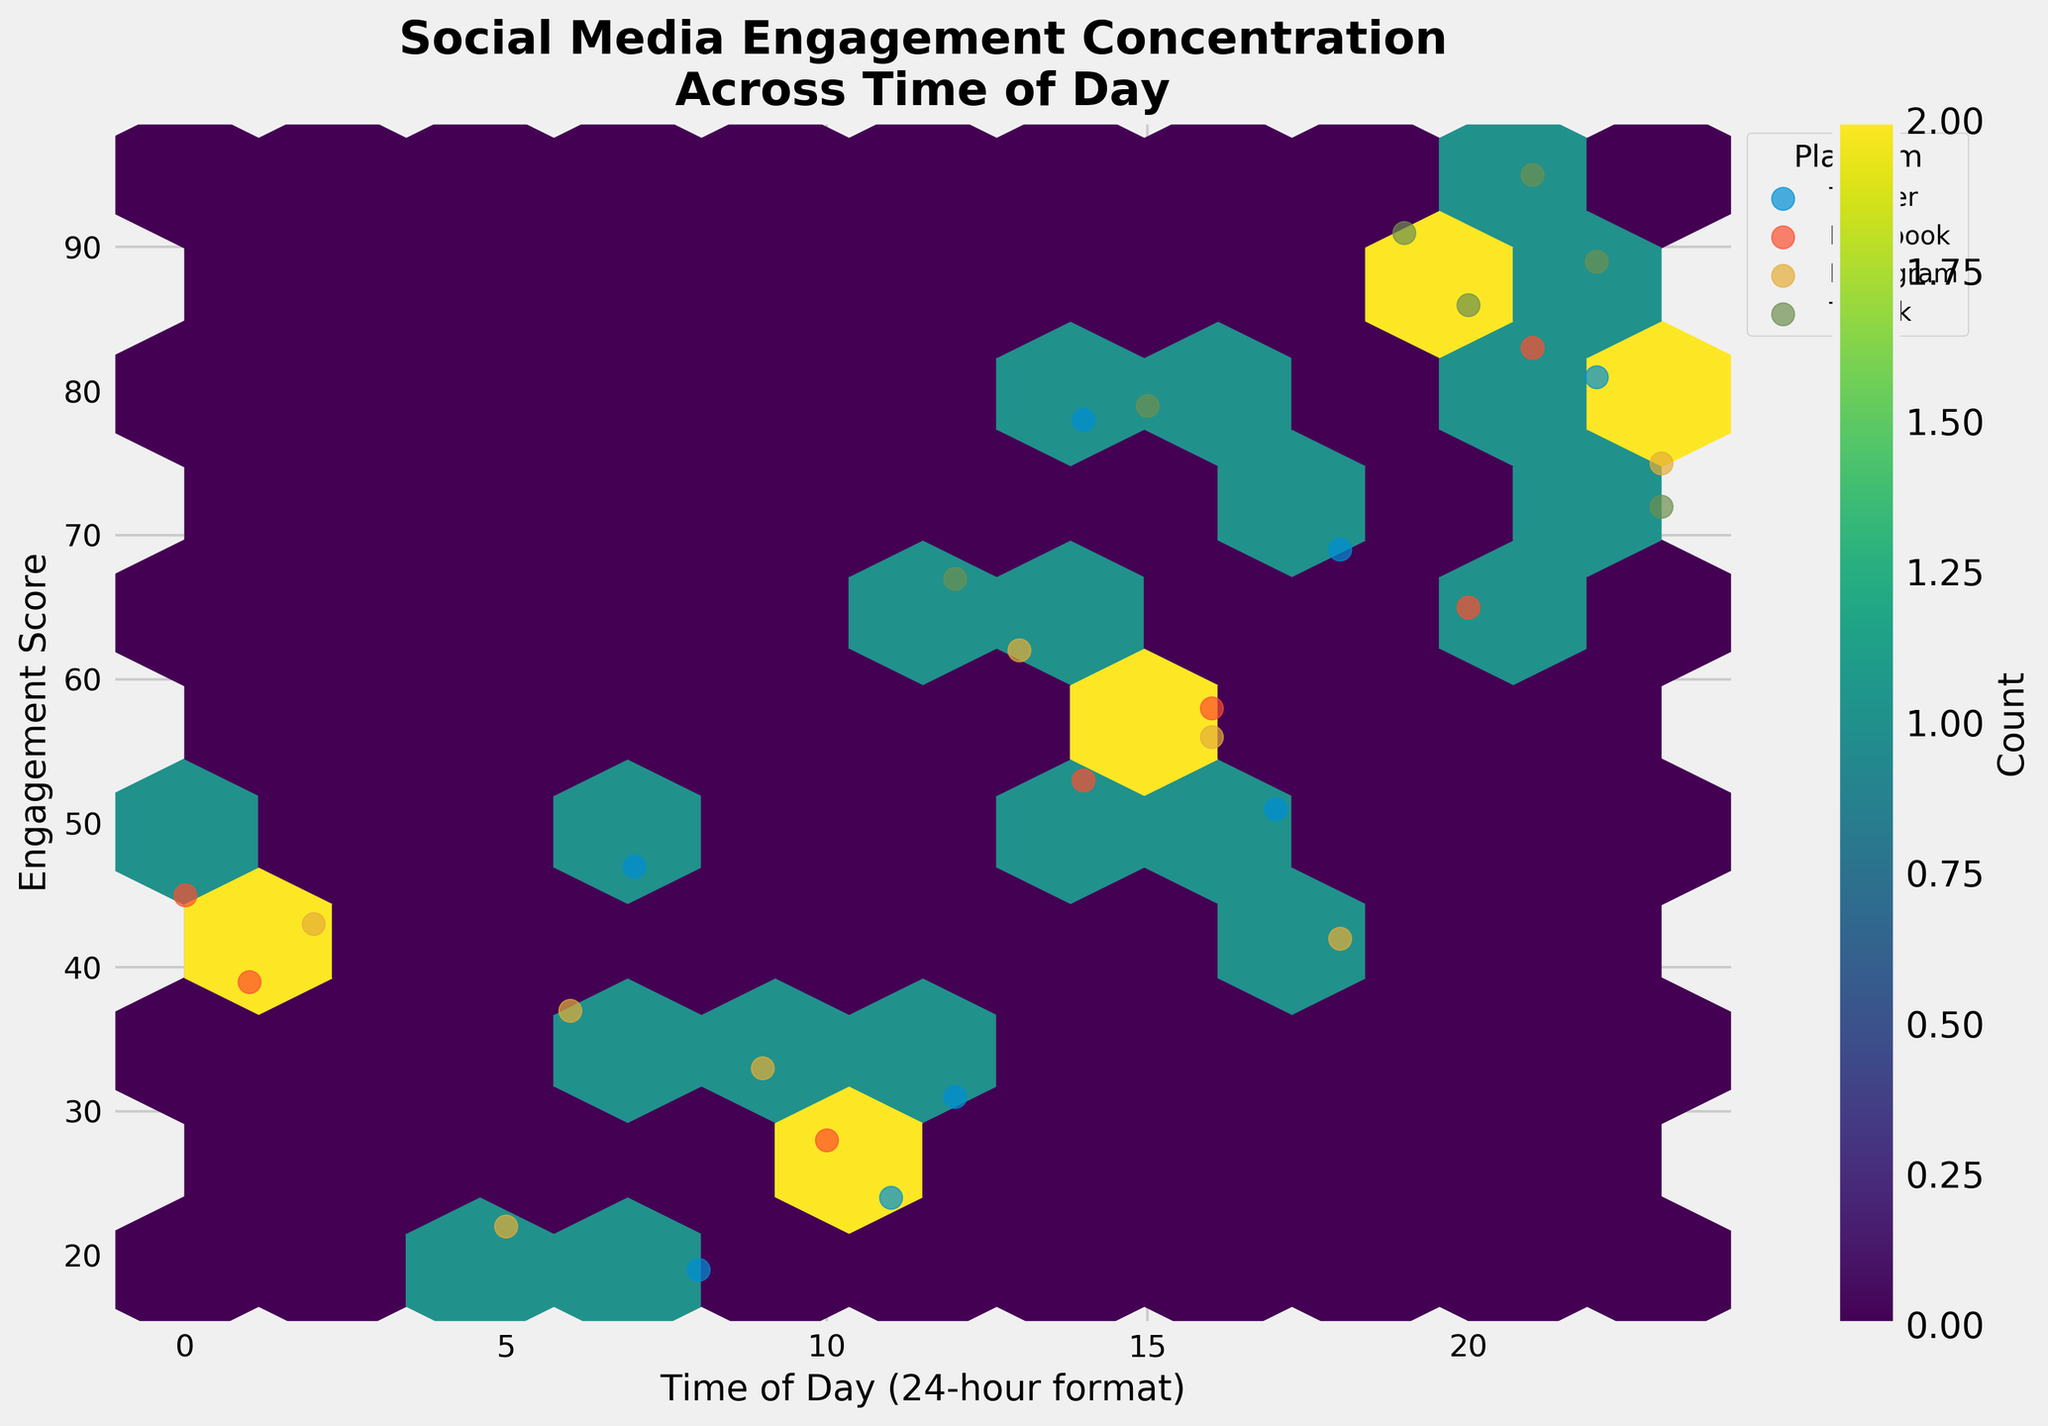What is the title of the Hexbin Plot? The title is displayed at the top of the figure and summarizes the content of the plot. It reads "Social Media Engagement Concentration\nAcross Time of Day".
Answer: Social Media Engagement Concentration\nAcross Time of Day What are the labels for the x-axis and y-axis? The labels are indicated on the respective axes. The x-axis is labeled "Time of Day (24-hour format)" and the y-axis is labeled "Engagement Score".
Answer: Time of Day (24-hour format), Engagement Score What color is used to represent the hexagons in the Hexbin Plot? The color of the hexagons is described by the color map used in the plot, which in this case is 'viridis', spanning from shades of purple to yellow.
Answer: Shades of purple to yellow Which platform has the highest engagement score, and at what time? Observing the scatter points superimposed on the hexagons, the platform with the highest engagement score is TikTok, particularly noticeable at 21:00 with an engagement score of 95.
Answer: TikTok at 21:00 Around which time of day is the concentration of high engagement scores most prominent? Analyzing the density of the hexagons and their placement, the highest concentration of engagement scores tends to appear around the later hours of the day, particularly between 18:00 and 23:00.
Answer: 18:00 to 23:00 How many platforms are represented in the Hexbin Plot, and what are they? The platforms are indicated by the legend on the right side. From the plot, there are four platforms: Twitter, Facebook, Instagram, and TikTok.
Answer: Four: Twitter, Facebook, Instagram, TikTok What is the average engagement score for Facebook posts made after 18:00? Identify the data points for Facebook after 18:00 and calculate their average. The data points are at 20:00 (65) and 21:00 (83). The average is (65 + 83)/2 = 74.
Answer: 74 Which platform has more engagement scores above 80, Twitter or TikTok? Count the scatter points above an engagement score of 80 for both platforms. TikTok has multiple points (21:00 with 95, 20:00 with 91, and others), while Twitter has fewer points above 80.
Answer: TikTok What engagement score do posts on Instagram made at 23:00 receive on average? Identify the engagement score for Instagram posts at 23:00, which is indicated as 75. Since there is only one value at that time, the average is straightforward.
Answer: 75 Is there a time of day when no platforms have high engagement scores (above 70)? Check the hexbin plot for areas devoid of high engagement scores. The early hours (midnight to early morning) and morning hours appear to lack high engagement scores.
Answer: Early hours and morning hours (midnight to early morning) 